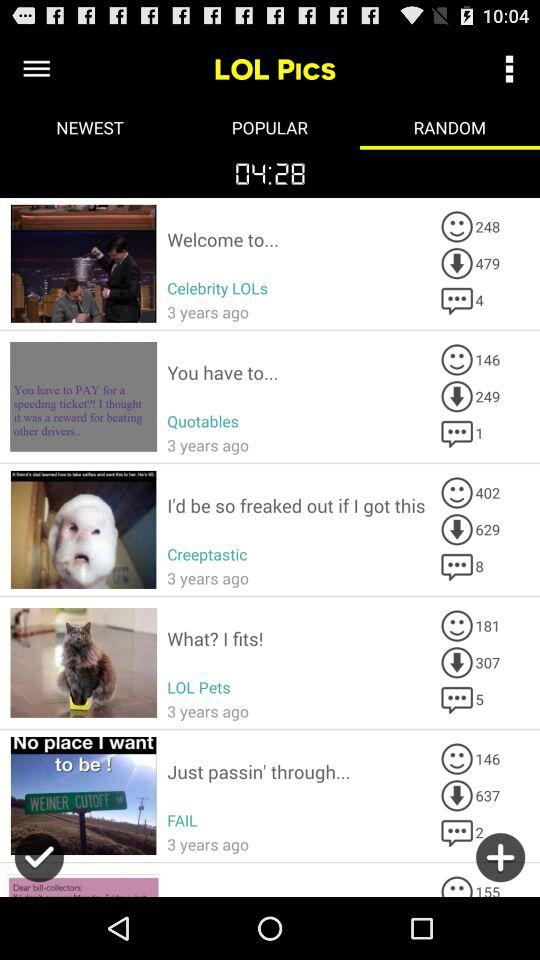How many people have reacted to the picture posted by "Celebrity LOLs"? The number of people that have reacted to the picture posted by "Celebrity LOLs" is 248. 